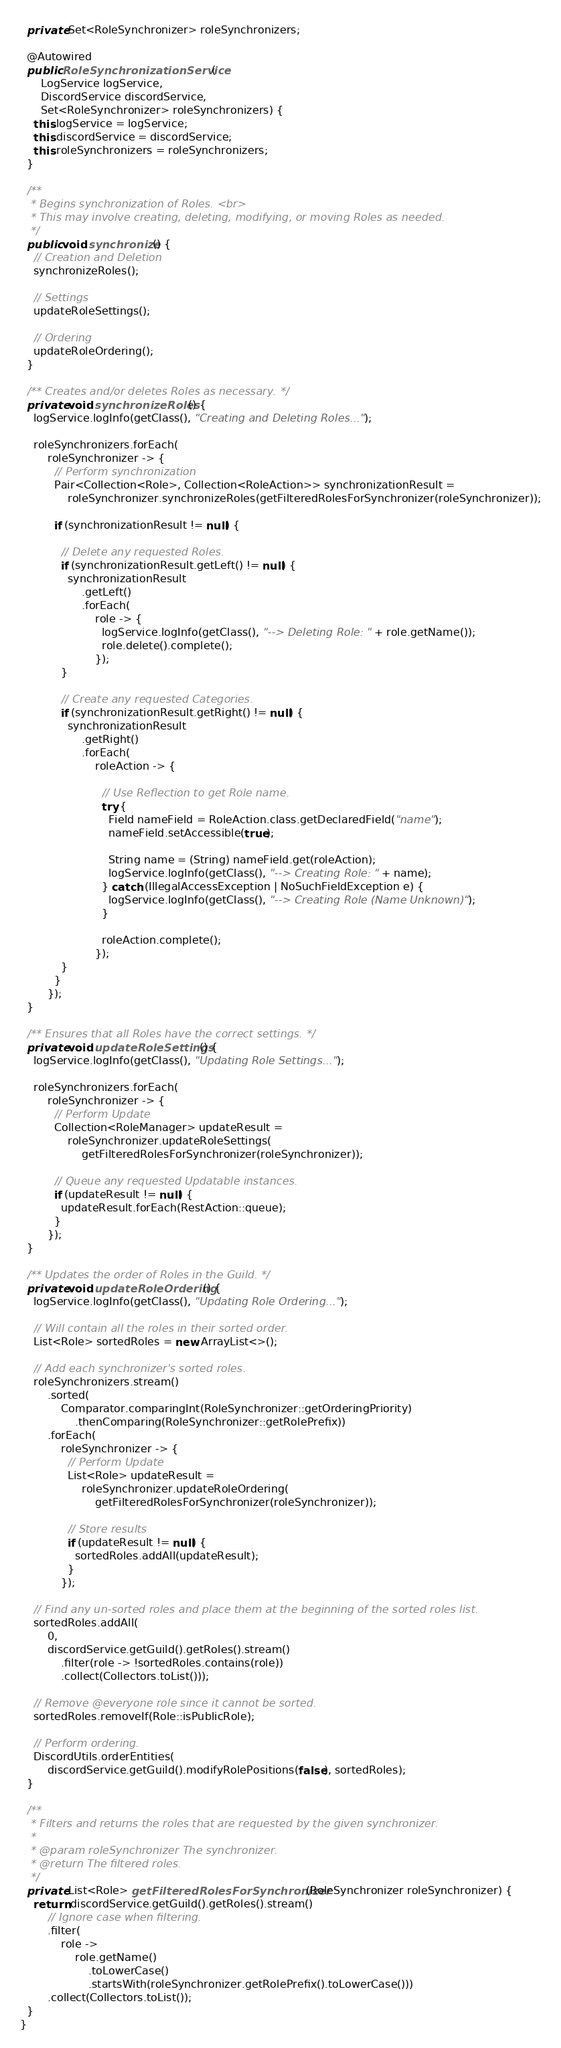<code> <loc_0><loc_0><loc_500><loc_500><_Java_>  private Set<RoleSynchronizer> roleSynchronizers;

  @Autowired
  public RoleSynchronizationService(
      LogService logService,
      DiscordService discordService,
      Set<RoleSynchronizer> roleSynchronizers) {
    this.logService = logService;
    this.discordService = discordService;
    this.roleSynchronizers = roleSynchronizers;
  }

  /**
   * Begins synchronization of Roles. <br>
   * This may involve creating, deleting, modifying, or moving Roles as needed.
   */
  public void synchronize() {
    // Creation and Deletion
    synchronizeRoles();

    // Settings
    updateRoleSettings();

    // Ordering
    updateRoleOrdering();
  }

  /** Creates and/or deletes Roles as necessary. */
  private void synchronizeRoles() {
    logService.logInfo(getClass(), "Creating and Deleting Roles...");

    roleSynchronizers.forEach(
        roleSynchronizer -> {
          // Perform synchronization
          Pair<Collection<Role>, Collection<RoleAction>> synchronizationResult =
              roleSynchronizer.synchronizeRoles(getFilteredRolesForSynchronizer(roleSynchronizer));

          if (synchronizationResult != null) {

            // Delete any requested Roles.
            if (synchronizationResult.getLeft() != null) {
              synchronizationResult
                  .getLeft()
                  .forEach(
                      role -> {
                        logService.logInfo(getClass(), "--> Deleting Role: " + role.getName());
                        role.delete().complete();
                      });
            }

            // Create any requested Categories.
            if (synchronizationResult.getRight() != null) {
              synchronizationResult
                  .getRight()
                  .forEach(
                      roleAction -> {

                        // Use Reflection to get Role name.
                        try {
                          Field nameField = RoleAction.class.getDeclaredField("name");
                          nameField.setAccessible(true);

                          String name = (String) nameField.get(roleAction);
                          logService.logInfo(getClass(), "--> Creating Role: " + name);
                        } catch (IllegalAccessException | NoSuchFieldException e) {
                          logService.logInfo(getClass(), "--> Creating Role (Name Unknown)");
                        }

                        roleAction.complete();
                      });
            }
          }
        });
  }

  /** Ensures that all Roles have the correct settings. */
  private void updateRoleSettings() {
    logService.logInfo(getClass(), "Updating Role Settings...");

    roleSynchronizers.forEach(
        roleSynchronizer -> {
          // Perform Update
          Collection<RoleManager> updateResult =
              roleSynchronizer.updateRoleSettings(
                  getFilteredRolesForSynchronizer(roleSynchronizer));

          // Queue any requested Updatable instances.
          if (updateResult != null) {
            updateResult.forEach(RestAction::queue);
          }
        });
  }

  /** Updates the order of Roles in the Guild. */
  private void updateRoleOrdering() {
    logService.logInfo(getClass(), "Updating Role Ordering...");

    // Will contain all the roles in their sorted order.
    List<Role> sortedRoles = new ArrayList<>();

    // Add each synchronizer's sorted roles.
    roleSynchronizers.stream()
        .sorted(
            Comparator.comparingInt(RoleSynchronizer::getOrderingPriority)
                .thenComparing(RoleSynchronizer::getRolePrefix))
        .forEach(
            roleSynchronizer -> {
              // Perform Update
              List<Role> updateResult =
                  roleSynchronizer.updateRoleOrdering(
                      getFilteredRolesForSynchronizer(roleSynchronizer));

              // Store results
              if (updateResult != null) {
                sortedRoles.addAll(updateResult);
              }
            });

    // Find any un-sorted roles and place them at the beginning of the sorted roles list.
    sortedRoles.addAll(
        0,
        discordService.getGuild().getRoles().stream()
            .filter(role -> !sortedRoles.contains(role))
            .collect(Collectors.toList()));

    // Remove @everyone role since it cannot be sorted.
    sortedRoles.removeIf(Role::isPublicRole);

    // Perform ordering.
    DiscordUtils.orderEntities(
        discordService.getGuild().modifyRolePositions(false), sortedRoles);
  }

  /**
   * Filters and returns the roles that are requested by the given synchronizer.
   *
   * @param roleSynchronizer The synchronizer.
   * @return The filtered roles.
   */
  private List<Role> getFilteredRolesForSynchronizer(RoleSynchronizer roleSynchronizer) {
    return discordService.getGuild().getRoles().stream()
        // Ignore case when filtering.
        .filter(
            role ->
                role.getName()
                    .toLowerCase()
                    .startsWith(roleSynchronizer.getRolePrefix().toLowerCase()))
        .collect(Collectors.toList());
  }
}
</code> 